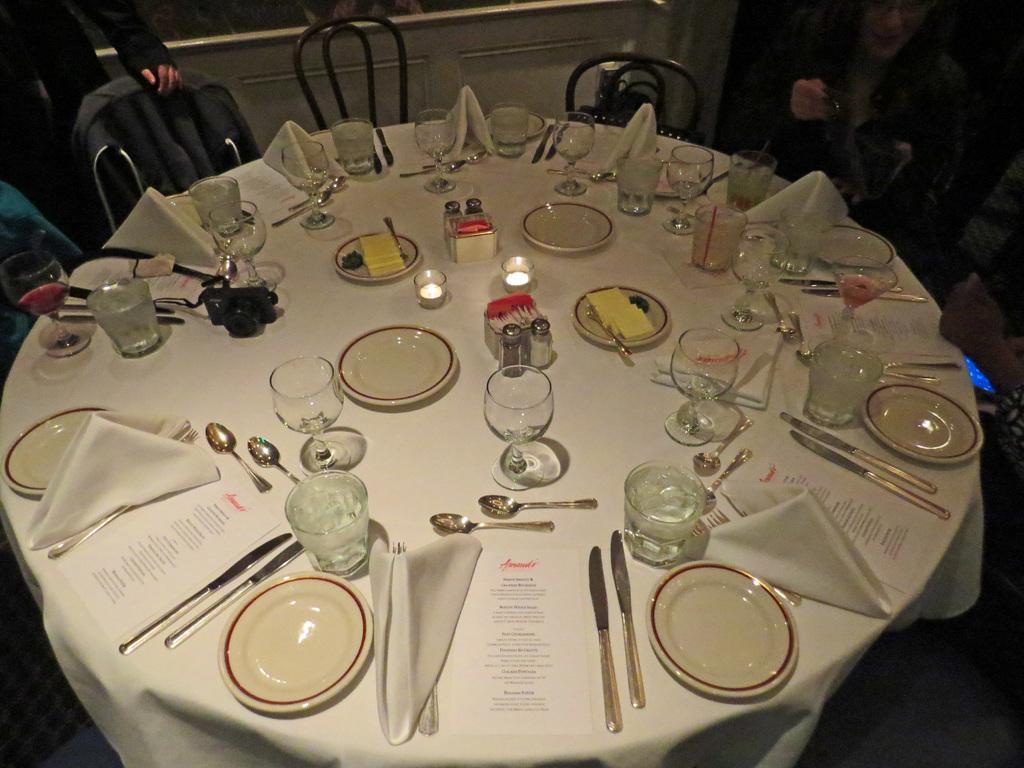Can you describe this image briefly? In this image we can see a table with white color table cloth on which we can see many plates, knives, spoons, menu cards, glasses, candles, camera, clothes and few more things are kept. Here we can see the chairs and few people sitting on the chair and here we can see a person is standing. 